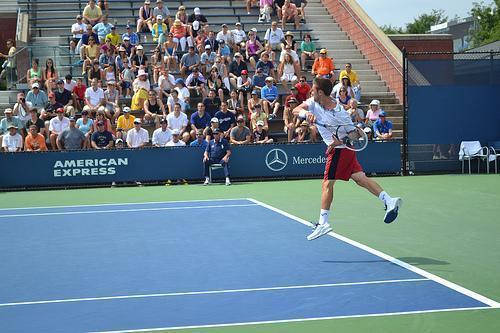How many people are playing tennis?
Give a very brief answer. 1. 